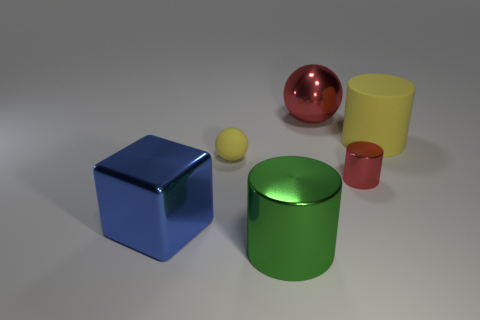What is the color of the large shiny thing that is the same shape as the small rubber object?
Ensure brevity in your answer.  Red. There is a sphere behind the yellow rubber sphere; is its size the same as the small matte sphere?
Keep it short and to the point. No. How big is the matte thing on the right side of the tiny shiny cylinder that is in front of the yellow rubber cylinder?
Give a very brief answer. Large. Does the large red thing have the same material as the object in front of the large block?
Your response must be concise. Yes. Is the number of metal cylinders right of the big red ball less than the number of tiny rubber things that are on the right side of the big yellow rubber cylinder?
Provide a short and direct response. No. The tiny cylinder that is the same material as the big red ball is what color?
Give a very brief answer. Red. There is a shiny cylinder right of the big green cylinder; is there a large green object that is behind it?
Offer a very short reply. No. The sphere that is the same size as the yellow rubber cylinder is what color?
Give a very brief answer. Red. What number of objects are small red cylinders or small yellow rubber spheres?
Your response must be concise. 2. There is a metal cylinder to the left of the big sphere that is behind the metal thing that is on the left side of the big green cylinder; what is its size?
Your answer should be compact. Large. 